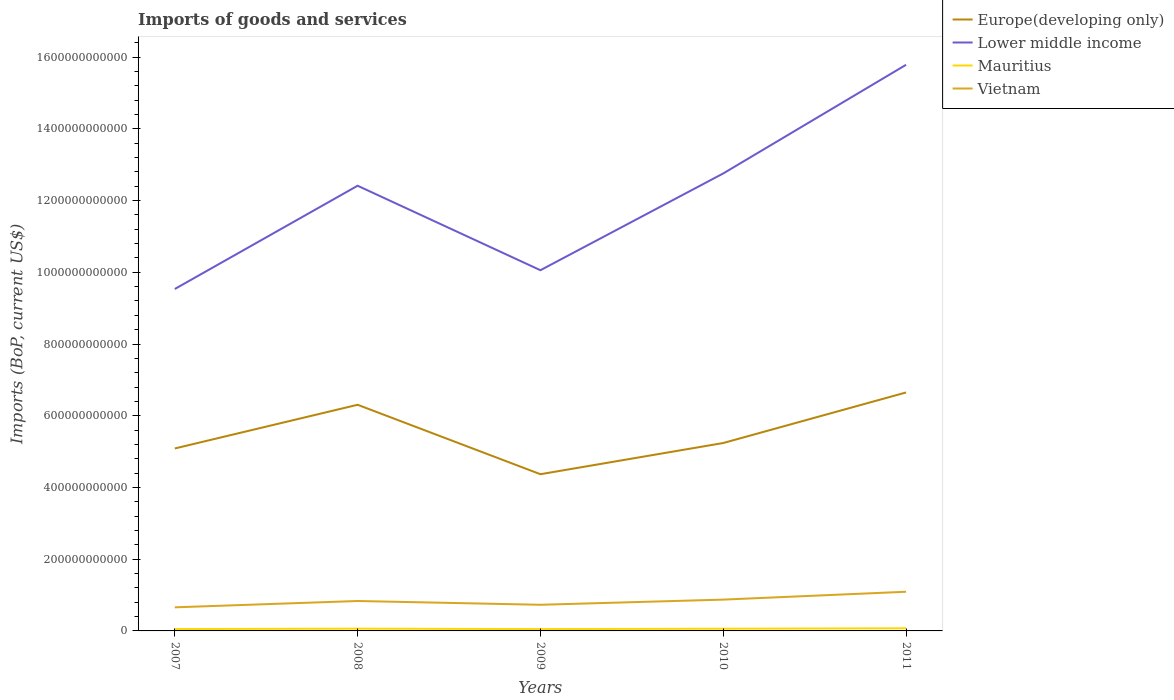How many different coloured lines are there?
Provide a succinct answer. 4. Does the line corresponding to Mauritius intersect with the line corresponding to Europe(developing only)?
Provide a short and direct response. No. Is the number of lines equal to the number of legend labels?
Ensure brevity in your answer.  Yes. Across all years, what is the maximum amount spent on imports in Mauritius?
Your answer should be compact. 5.11e+09. What is the total amount spent on imports in Europe(developing only) in the graph?
Provide a succinct answer. 7.18e+1. What is the difference between the highest and the second highest amount spent on imports in Vietnam?
Ensure brevity in your answer.  4.34e+1. What is the difference between the highest and the lowest amount spent on imports in Europe(developing only)?
Give a very brief answer. 2. Is the amount spent on imports in Vietnam strictly greater than the amount spent on imports in Europe(developing only) over the years?
Your answer should be very brief. Yes. How many years are there in the graph?
Offer a terse response. 5. What is the difference between two consecutive major ticks on the Y-axis?
Make the answer very short. 2.00e+11. Are the values on the major ticks of Y-axis written in scientific E-notation?
Keep it short and to the point. No. Does the graph contain any zero values?
Your answer should be compact. No. Where does the legend appear in the graph?
Your answer should be very brief. Top right. How many legend labels are there?
Offer a terse response. 4. What is the title of the graph?
Provide a short and direct response. Imports of goods and services. Does "Benin" appear as one of the legend labels in the graph?
Provide a succinct answer. No. What is the label or title of the Y-axis?
Provide a succinct answer. Imports (BoP, current US$). What is the Imports (BoP, current US$) in Europe(developing only) in 2007?
Your response must be concise. 5.09e+11. What is the Imports (BoP, current US$) in Lower middle income in 2007?
Your answer should be compact. 9.53e+11. What is the Imports (BoP, current US$) in Mauritius in 2007?
Give a very brief answer. 5.23e+09. What is the Imports (BoP, current US$) of Vietnam in 2007?
Your answer should be compact. 6.58e+1. What is the Imports (BoP, current US$) of Europe(developing only) in 2008?
Ensure brevity in your answer.  6.31e+11. What is the Imports (BoP, current US$) in Lower middle income in 2008?
Ensure brevity in your answer.  1.24e+12. What is the Imports (BoP, current US$) of Mauritius in 2008?
Give a very brief answer. 6.31e+09. What is the Imports (BoP, current US$) of Vietnam in 2008?
Make the answer very short. 8.34e+1. What is the Imports (BoP, current US$) in Europe(developing only) in 2009?
Your response must be concise. 4.37e+11. What is the Imports (BoP, current US$) of Lower middle income in 2009?
Your answer should be compact. 1.01e+12. What is the Imports (BoP, current US$) of Mauritius in 2009?
Offer a terse response. 5.11e+09. What is the Imports (BoP, current US$) in Vietnam in 2009?
Offer a very short reply. 7.29e+1. What is the Imports (BoP, current US$) of Europe(developing only) in 2010?
Your answer should be compact. 5.24e+11. What is the Imports (BoP, current US$) in Lower middle income in 2010?
Your answer should be very brief. 1.28e+12. What is the Imports (BoP, current US$) of Mauritius in 2010?
Provide a short and direct response. 6.14e+09. What is the Imports (BoP, current US$) in Vietnam in 2010?
Your answer should be compact. 8.73e+1. What is the Imports (BoP, current US$) of Europe(developing only) in 2011?
Ensure brevity in your answer.  6.65e+11. What is the Imports (BoP, current US$) of Lower middle income in 2011?
Your response must be concise. 1.58e+12. What is the Imports (BoP, current US$) in Mauritius in 2011?
Your answer should be very brief. 7.39e+09. What is the Imports (BoP, current US$) in Vietnam in 2011?
Your answer should be compact. 1.09e+11. Across all years, what is the maximum Imports (BoP, current US$) in Europe(developing only)?
Give a very brief answer. 6.65e+11. Across all years, what is the maximum Imports (BoP, current US$) in Lower middle income?
Give a very brief answer. 1.58e+12. Across all years, what is the maximum Imports (BoP, current US$) of Mauritius?
Your answer should be very brief. 7.39e+09. Across all years, what is the maximum Imports (BoP, current US$) in Vietnam?
Keep it short and to the point. 1.09e+11. Across all years, what is the minimum Imports (BoP, current US$) in Europe(developing only)?
Ensure brevity in your answer.  4.37e+11. Across all years, what is the minimum Imports (BoP, current US$) in Lower middle income?
Keep it short and to the point. 9.53e+11. Across all years, what is the minimum Imports (BoP, current US$) in Mauritius?
Ensure brevity in your answer.  5.11e+09. Across all years, what is the minimum Imports (BoP, current US$) of Vietnam?
Make the answer very short. 6.58e+1. What is the total Imports (BoP, current US$) in Europe(developing only) in the graph?
Ensure brevity in your answer.  2.77e+12. What is the total Imports (BoP, current US$) in Lower middle income in the graph?
Ensure brevity in your answer.  6.05e+12. What is the total Imports (BoP, current US$) in Mauritius in the graph?
Ensure brevity in your answer.  3.02e+1. What is the total Imports (BoP, current US$) in Vietnam in the graph?
Make the answer very short. 4.19e+11. What is the difference between the Imports (BoP, current US$) of Europe(developing only) in 2007 and that in 2008?
Offer a very short reply. -1.22e+11. What is the difference between the Imports (BoP, current US$) of Lower middle income in 2007 and that in 2008?
Provide a succinct answer. -2.88e+11. What is the difference between the Imports (BoP, current US$) of Mauritius in 2007 and that in 2008?
Your answer should be compact. -1.08e+09. What is the difference between the Imports (BoP, current US$) in Vietnam in 2007 and that in 2008?
Offer a terse response. -1.76e+1. What is the difference between the Imports (BoP, current US$) in Europe(developing only) in 2007 and that in 2009?
Offer a very short reply. 7.18e+1. What is the difference between the Imports (BoP, current US$) of Lower middle income in 2007 and that in 2009?
Provide a succinct answer. -5.24e+1. What is the difference between the Imports (BoP, current US$) of Mauritius in 2007 and that in 2009?
Give a very brief answer. 1.14e+08. What is the difference between the Imports (BoP, current US$) in Vietnam in 2007 and that in 2009?
Keep it short and to the point. -7.11e+09. What is the difference between the Imports (BoP, current US$) of Europe(developing only) in 2007 and that in 2010?
Keep it short and to the point. -1.52e+1. What is the difference between the Imports (BoP, current US$) in Lower middle income in 2007 and that in 2010?
Provide a succinct answer. -3.22e+11. What is the difference between the Imports (BoP, current US$) in Mauritius in 2007 and that in 2010?
Ensure brevity in your answer.  -9.11e+08. What is the difference between the Imports (BoP, current US$) of Vietnam in 2007 and that in 2010?
Ensure brevity in your answer.  -2.15e+1. What is the difference between the Imports (BoP, current US$) of Europe(developing only) in 2007 and that in 2011?
Make the answer very short. -1.56e+11. What is the difference between the Imports (BoP, current US$) in Lower middle income in 2007 and that in 2011?
Your answer should be very brief. -6.25e+11. What is the difference between the Imports (BoP, current US$) in Mauritius in 2007 and that in 2011?
Offer a terse response. -2.16e+09. What is the difference between the Imports (BoP, current US$) of Vietnam in 2007 and that in 2011?
Keep it short and to the point. -4.34e+1. What is the difference between the Imports (BoP, current US$) of Europe(developing only) in 2008 and that in 2009?
Offer a terse response. 1.94e+11. What is the difference between the Imports (BoP, current US$) of Lower middle income in 2008 and that in 2009?
Your answer should be compact. 2.36e+11. What is the difference between the Imports (BoP, current US$) of Mauritius in 2008 and that in 2009?
Your answer should be compact. 1.19e+09. What is the difference between the Imports (BoP, current US$) in Vietnam in 2008 and that in 2009?
Give a very brief answer. 1.05e+1. What is the difference between the Imports (BoP, current US$) of Europe(developing only) in 2008 and that in 2010?
Your response must be concise. 1.07e+11. What is the difference between the Imports (BoP, current US$) of Lower middle income in 2008 and that in 2010?
Your answer should be very brief. -3.43e+1. What is the difference between the Imports (BoP, current US$) of Mauritius in 2008 and that in 2010?
Your answer should be very brief. 1.70e+08. What is the difference between the Imports (BoP, current US$) in Vietnam in 2008 and that in 2010?
Keep it short and to the point. -3.87e+09. What is the difference between the Imports (BoP, current US$) of Europe(developing only) in 2008 and that in 2011?
Make the answer very short. -3.43e+1. What is the difference between the Imports (BoP, current US$) of Lower middle income in 2008 and that in 2011?
Provide a succinct answer. -3.37e+11. What is the difference between the Imports (BoP, current US$) of Mauritius in 2008 and that in 2011?
Give a very brief answer. -1.08e+09. What is the difference between the Imports (BoP, current US$) of Vietnam in 2008 and that in 2011?
Offer a terse response. -2.58e+1. What is the difference between the Imports (BoP, current US$) of Europe(developing only) in 2009 and that in 2010?
Offer a terse response. -8.70e+1. What is the difference between the Imports (BoP, current US$) of Lower middle income in 2009 and that in 2010?
Your answer should be very brief. -2.70e+11. What is the difference between the Imports (BoP, current US$) of Mauritius in 2009 and that in 2010?
Your answer should be compact. -1.02e+09. What is the difference between the Imports (BoP, current US$) in Vietnam in 2009 and that in 2010?
Provide a short and direct response. -1.44e+1. What is the difference between the Imports (BoP, current US$) in Europe(developing only) in 2009 and that in 2011?
Provide a succinct answer. -2.28e+11. What is the difference between the Imports (BoP, current US$) of Lower middle income in 2009 and that in 2011?
Offer a terse response. -5.73e+11. What is the difference between the Imports (BoP, current US$) of Mauritius in 2009 and that in 2011?
Offer a very short reply. -2.28e+09. What is the difference between the Imports (BoP, current US$) in Vietnam in 2009 and that in 2011?
Offer a terse response. -3.63e+1. What is the difference between the Imports (BoP, current US$) in Europe(developing only) in 2010 and that in 2011?
Your response must be concise. -1.41e+11. What is the difference between the Imports (BoP, current US$) of Lower middle income in 2010 and that in 2011?
Keep it short and to the point. -3.03e+11. What is the difference between the Imports (BoP, current US$) in Mauritius in 2010 and that in 2011?
Your response must be concise. -1.25e+09. What is the difference between the Imports (BoP, current US$) in Vietnam in 2010 and that in 2011?
Offer a very short reply. -2.19e+1. What is the difference between the Imports (BoP, current US$) in Europe(developing only) in 2007 and the Imports (BoP, current US$) in Lower middle income in 2008?
Ensure brevity in your answer.  -7.33e+11. What is the difference between the Imports (BoP, current US$) in Europe(developing only) in 2007 and the Imports (BoP, current US$) in Mauritius in 2008?
Provide a succinct answer. 5.02e+11. What is the difference between the Imports (BoP, current US$) in Europe(developing only) in 2007 and the Imports (BoP, current US$) in Vietnam in 2008?
Ensure brevity in your answer.  4.25e+11. What is the difference between the Imports (BoP, current US$) in Lower middle income in 2007 and the Imports (BoP, current US$) in Mauritius in 2008?
Your answer should be very brief. 9.47e+11. What is the difference between the Imports (BoP, current US$) of Lower middle income in 2007 and the Imports (BoP, current US$) of Vietnam in 2008?
Keep it short and to the point. 8.70e+11. What is the difference between the Imports (BoP, current US$) of Mauritius in 2007 and the Imports (BoP, current US$) of Vietnam in 2008?
Keep it short and to the point. -7.82e+1. What is the difference between the Imports (BoP, current US$) of Europe(developing only) in 2007 and the Imports (BoP, current US$) of Lower middle income in 2009?
Your answer should be very brief. -4.97e+11. What is the difference between the Imports (BoP, current US$) in Europe(developing only) in 2007 and the Imports (BoP, current US$) in Mauritius in 2009?
Your answer should be very brief. 5.04e+11. What is the difference between the Imports (BoP, current US$) in Europe(developing only) in 2007 and the Imports (BoP, current US$) in Vietnam in 2009?
Give a very brief answer. 4.36e+11. What is the difference between the Imports (BoP, current US$) of Lower middle income in 2007 and the Imports (BoP, current US$) of Mauritius in 2009?
Keep it short and to the point. 9.48e+11. What is the difference between the Imports (BoP, current US$) in Lower middle income in 2007 and the Imports (BoP, current US$) in Vietnam in 2009?
Your response must be concise. 8.81e+11. What is the difference between the Imports (BoP, current US$) in Mauritius in 2007 and the Imports (BoP, current US$) in Vietnam in 2009?
Your answer should be compact. -6.77e+1. What is the difference between the Imports (BoP, current US$) in Europe(developing only) in 2007 and the Imports (BoP, current US$) in Lower middle income in 2010?
Ensure brevity in your answer.  -7.67e+11. What is the difference between the Imports (BoP, current US$) in Europe(developing only) in 2007 and the Imports (BoP, current US$) in Mauritius in 2010?
Your response must be concise. 5.03e+11. What is the difference between the Imports (BoP, current US$) in Europe(developing only) in 2007 and the Imports (BoP, current US$) in Vietnam in 2010?
Your answer should be compact. 4.21e+11. What is the difference between the Imports (BoP, current US$) of Lower middle income in 2007 and the Imports (BoP, current US$) of Mauritius in 2010?
Provide a short and direct response. 9.47e+11. What is the difference between the Imports (BoP, current US$) of Lower middle income in 2007 and the Imports (BoP, current US$) of Vietnam in 2010?
Ensure brevity in your answer.  8.66e+11. What is the difference between the Imports (BoP, current US$) in Mauritius in 2007 and the Imports (BoP, current US$) in Vietnam in 2010?
Your response must be concise. -8.21e+1. What is the difference between the Imports (BoP, current US$) in Europe(developing only) in 2007 and the Imports (BoP, current US$) in Lower middle income in 2011?
Your answer should be compact. -1.07e+12. What is the difference between the Imports (BoP, current US$) in Europe(developing only) in 2007 and the Imports (BoP, current US$) in Mauritius in 2011?
Make the answer very short. 5.01e+11. What is the difference between the Imports (BoP, current US$) in Europe(developing only) in 2007 and the Imports (BoP, current US$) in Vietnam in 2011?
Give a very brief answer. 4.00e+11. What is the difference between the Imports (BoP, current US$) of Lower middle income in 2007 and the Imports (BoP, current US$) of Mauritius in 2011?
Your response must be concise. 9.46e+11. What is the difference between the Imports (BoP, current US$) of Lower middle income in 2007 and the Imports (BoP, current US$) of Vietnam in 2011?
Provide a short and direct response. 8.44e+11. What is the difference between the Imports (BoP, current US$) in Mauritius in 2007 and the Imports (BoP, current US$) in Vietnam in 2011?
Give a very brief answer. -1.04e+11. What is the difference between the Imports (BoP, current US$) of Europe(developing only) in 2008 and the Imports (BoP, current US$) of Lower middle income in 2009?
Provide a succinct answer. -3.75e+11. What is the difference between the Imports (BoP, current US$) of Europe(developing only) in 2008 and the Imports (BoP, current US$) of Mauritius in 2009?
Provide a succinct answer. 6.25e+11. What is the difference between the Imports (BoP, current US$) of Europe(developing only) in 2008 and the Imports (BoP, current US$) of Vietnam in 2009?
Give a very brief answer. 5.58e+11. What is the difference between the Imports (BoP, current US$) in Lower middle income in 2008 and the Imports (BoP, current US$) in Mauritius in 2009?
Ensure brevity in your answer.  1.24e+12. What is the difference between the Imports (BoP, current US$) of Lower middle income in 2008 and the Imports (BoP, current US$) of Vietnam in 2009?
Ensure brevity in your answer.  1.17e+12. What is the difference between the Imports (BoP, current US$) of Mauritius in 2008 and the Imports (BoP, current US$) of Vietnam in 2009?
Your answer should be compact. -6.66e+1. What is the difference between the Imports (BoP, current US$) in Europe(developing only) in 2008 and the Imports (BoP, current US$) in Lower middle income in 2010?
Ensure brevity in your answer.  -6.45e+11. What is the difference between the Imports (BoP, current US$) of Europe(developing only) in 2008 and the Imports (BoP, current US$) of Mauritius in 2010?
Provide a short and direct response. 6.24e+11. What is the difference between the Imports (BoP, current US$) in Europe(developing only) in 2008 and the Imports (BoP, current US$) in Vietnam in 2010?
Your answer should be compact. 5.43e+11. What is the difference between the Imports (BoP, current US$) of Lower middle income in 2008 and the Imports (BoP, current US$) of Mauritius in 2010?
Make the answer very short. 1.24e+12. What is the difference between the Imports (BoP, current US$) in Lower middle income in 2008 and the Imports (BoP, current US$) in Vietnam in 2010?
Offer a terse response. 1.15e+12. What is the difference between the Imports (BoP, current US$) of Mauritius in 2008 and the Imports (BoP, current US$) of Vietnam in 2010?
Your answer should be compact. -8.10e+1. What is the difference between the Imports (BoP, current US$) in Europe(developing only) in 2008 and the Imports (BoP, current US$) in Lower middle income in 2011?
Offer a terse response. -9.48e+11. What is the difference between the Imports (BoP, current US$) in Europe(developing only) in 2008 and the Imports (BoP, current US$) in Mauritius in 2011?
Offer a terse response. 6.23e+11. What is the difference between the Imports (BoP, current US$) of Europe(developing only) in 2008 and the Imports (BoP, current US$) of Vietnam in 2011?
Keep it short and to the point. 5.21e+11. What is the difference between the Imports (BoP, current US$) in Lower middle income in 2008 and the Imports (BoP, current US$) in Mauritius in 2011?
Your response must be concise. 1.23e+12. What is the difference between the Imports (BoP, current US$) in Lower middle income in 2008 and the Imports (BoP, current US$) in Vietnam in 2011?
Your response must be concise. 1.13e+12. What is the difference between the Imports (BoP, current US$) in Mauritius in 2008 and the Imports (BoP, current US$) in Vietnam in 2011?
Offer a very short reply. -1.03e+11. What is the difference between the Imports (BoP, current US$) in Europe(developing only) in 2009 and the Imports (BoP, current US$) in Lower middle income in 2010?
Make the answer very short. -8.39e+11. What is the difference between the Imports (BoP, current US$) in Europe(developing only) in 2009 and the Imports (BoP, current US$) in Mauritius in 2010?
Ensure brevity in your answer.  4.31e+11. What is the difference between the Imports (BoP, current US$) of Europe(developing only) in 2009 and the Imports (BoP, current US$) of Vietnam in 2010?
Give a very brief answer. 3.50e+11. What is the difference between the Imports (BoP, current US$) in Lower middle income in 2009 and the Imports (BoP, current US$) in Mauritius in 2010?
Offer a very short reply. 1.00e+12. What is the difference between the Imports (BoP, current US$) of Lower middle income in 2009 and the Imports (BoP, current US$) of Vietnam in 2010?
Keep it short and to the point. 9.19e+11. What is the difference between the Imports (BoP, current US$) in Mauritius in 2009 and the Imports (BoP, current US$) in Vietnam in 2010?
Your answer should be very brief. -8.22e+1. What is the difference between the Imports (BoP, current US$) in Europe(developing only) in 2009 and the Imports (BoP, current US$) in Lower middle income in 2011?
Offer a very short reply. -1.14e+12. What is the difference between the Imports (BoP, current US$) in Europe(developing only) in 2009 and the Imports (BoP, current US$) in Mauritius in 2011?
Make the answer very short. 4.30e+11. What is the difference between the Imports (BoP, current US$) of Europe(developing only) in 2009 and the Imports (BoP, current US$) of Vietnam in 2011?
Keep it short and to the point. 3.28e+11. What is the difference between the Imports (BoP, current US$) of Lower middle income in 2009 and the Imports (BoP, current US$) of Mauritius in 2011?
Give a very brief answer. 9.98e+11. What is the difference between the Imports (BoP, current US$) in Lower middle income in 2009 and the Imports (BoP, current US$) in Vietnam in 2011?
Make the answer very short. 8.97e+11. What is the difference between the Imports (BoP, current US$) in Mauritius in 2009 and the Imports (BoP, current US$) in Vietnam in 2011?
Offer a very short reply. -1.04e+11. What is the difference between the Imports (BoP, current US$) in Europe(developing only) in 2010 and the Imports (BoP, current US$) in Lower middle income in 2011?
Ensure brevity in your answer.  -1.05e+12. What is the difference between the Imports (BoP, current US$) of Europe(developing only) in 2010 and the Imports (BoP, current US$) of Mauritius in 2011?
Provide a short and direct response. 5.17e+11. What is the difference between the Imports (BoP, current US$) in Europe(developing only) in 2010 and the Imports (BoP, current US$) in Vietnam in 2011?
Offer a very short reply. 4.15e+11. What is the difference between the Imports (BoP, current US$) in Lower middle income in 2010 and the Imports (BoP, current US$) in Mauritius in 2011?
Ensure brevity in your answer.  1.27e+12. What is the difference between the Imports (BoP, current US$) in Lower middle income in 2010 and the Imports (BoP, current US$) in Vietnam in 2011?
Provide a short and direct response. 1.17e+12. What is the difference between the Imports (BoP, current US$) in Mauritius in 2010 and the Imports (BoP, current US$) in Vietnam in 2011?
Make the answer very short. -1.03e+11. What is the average Imports (BoP, current US$) of Europe(developing only) per year?
Keep it short and to the point. 5.53e+11. What is the average Imports (BoP, current US$) of Lower middle income per year?
Provide a short and direct response. 1.21e+12. What is the average Imports (BoP, current US$) in Mauritius per year?
Your answer should be compact. 6.03e+09. What is the average Imports (BoP, current US$) in Vietnam per year?
Give a very brief answer. 8.37e+1. In the year 2007, what is the difference between the Imports (BoP, current US$) in Europe(developing only) and Imports (BoP, current US$) in Lower middle income?
Provide a short and direct response. -4.45e+11. In the year 2007, what is the difference between the Imports (BoP, current US$) in Europe(developing only) and Imports (BoP, current US$) in Mauritius?
Offer a terse response. 5.04e+11. In the year 2007, what is the difference between the Imports (BoP, current US$) in Europe(developing only) and Imports (BoP, current US$) in Vietnam?
Provide a succinct answer. 4.43e+11. In the year 2007, what is the difference between the Imports (BoP, current US$) in Lower middle income and Imports (BoP, current US$) in Mauritius?
Offer a terse response. 9.48e+11. In the year 2007, what is the difference between the Imports (BoP, current US$) in Lower middle income and Imports (BoP, current US$) in Vietnam?
Provide a succinct answer. 8.88e+11. In the year 2007, what is the difference between the Imports (BoP, current US$) of Mauritius and Imports (BoP, current US$) of Vietnam?
Your answer should be compact. -6.06e+1. In the year 2008, what is the difference between the Imports (BoP, current US$) in Europe(developing only) and Imports (BoP, current US$) in Lower middle income?
Provide a short and direct response. -6.11e+11. In the year 2008, what is the difference between the Imports (BoP, current US$) of Europe(developing only) and Imports (BoP, current US$) of Mauritius?
Give a very brief answer. 6.24e+11. In the year 2008, what is the difference between the Imports (BoP, current US$) of Europe(developing only) and Imports (BoP, current US$) of Vietnam?
Ensure brevity in your answer.  5.47e+11. In the year 2008, what is the difference between the Imports (BoP, current US$) in Lower middle income and Imports (BoP, current US$) in Mauritius?
Make the answer very short. 1.24e+12. In the year 2008, what is the difference between the Imports (BoP, current US$) in Lower middle income and Imports (BoP, current US$) in Vietnam?
Offer a terse response. 1.16e+12. In the year 2008, what is the difference between the Imports (BoP, current US$) in Mauritius and Imports (BoP, current US$) in Vietnam?
Ensure brevity in your answer.  -7.71e+1. In the year 2009, what is the difference between the Imports (BoP, current US$) in Europe(developing only) and Imports (BoP, current US$) in Lower middle income?
Give a very brief answer. -5.69e+11. In the year 2009, what is the difference between the Imports (BoP, current US$) in Europe(developing only) and Imports (BoP, current US$) in Mauritius?
Offer a terse response. 4.32e+11. In the year 2009, what is the difference between the Imports (BoP, current US$) in Europe(developing only) and Imports (BoP, current US$) in Vietnam?
Your answer should be compact. 3.64e+11. In the year 2009, what is the difference between the Imports (BoP, current US$) in Lower middle income and Imports (BoP, current US$) in Mauritius?
Ensure brevity in your answer.  1.00e+12. In the year 2009, what is the difference between the Imports (BoP, current US$) in Lower middle income and Imports (BoP, current US$) in Vietnam?
Your answer should be compact. 9.33e+11. In the year 2009, what is the difference between the Imports (BoP, current US$) in Mauritius and Imports (BoP, current US$) in Vietnam?
Your response must be concise. -6.78e+1. In the year 2010, what is the difference between the Imports (BoP, current US$) in Europe(developing only) and Imports (BoP, current US$) in Lower middle income?
Provide a short and direct response. -7.52e+11. In the year 2010, what is the difference between the Imports (BoP, current US$) in Europe(developing only) and Imports (BoP, current US$) in Mauritius?
Offer a very short reply. 5.18e+11. In the year 2010, what is the difference between the Imports (BoP, current US$) of Europe(developing only) and Imports (BoP, current US$) of Vietnam?
Offer a terse response. 4.37e+11. In the year 2010, what is the difference between the Imports (BoP, current US$) of Lower middle income and Imports (BoP, current US$) of Mauritius?
Your answer should be compact. 1.27e+12. In the year 2010, what is the difference between the Imports (BoP, current US$) in Lower middle income and Imports (BoP, current US$) in Vietnam?
Provide a succinct answer. 1.19e+12. In the year 2010, what is the difference between the Imports (BoP, current US$) in Mauritius and Imports (BoP, current US$) in Vietnam?
Make the answer very short. -8.12e+1. In the year 2011, what is the difference between the Imports (BoP, current US$) in Europe(developing only) and Imports (BoP, current US$) in Lower middle income?
Provide a short and direct response. -9.14e+11. In the year 2011, what is the difference between the Imports (BoP, current US$) of Europe(developing only) and Imports (BoP, current US$) of Mauritius?
Your answer should be compact. 6.58e+11. In the year 2011, what is the difference between the Imports (BoP, current US$) of Europe(developing only) and Imports (BoP, current US$) of Vietnam?
Give a very brief answer. 5.56e+11. In the year 2011, what is the difference between the Imports (BoP, current US$) of Lower middle income and Imports (BoP, current US$) of Mauritius?
Offer a very short reply. 1.57e+12. In the year 2011, what is the difference between the Imports (BoP, current US$) of Lower middle income and Imports (BoP, current US$) of Vietnam?
Your response must be concise. 1.47e+12. In the year 2011, what is the difference between the Imports (BoP, current US$) in Mauritius and Imports (BoP, current US$) in Vietnam?
Your answer should be compact. -1.02e+11. What is the ratio of the Imports (BoP, current US$) in Europe(developing only) in 2007 to that in 2008?
Give a very brief answer. 0.81. What is the ratio of the Imports (BoP, current US$) in Lower middle income in 2007 to that in 2008?
Keep it short and to the point. 0.77. What is the ratio of the Imports (BoP, current US$) of Mauritius in 2007 to that in 2008?
Your answer should be very brief. 0.83. What is the ratio of the Imports (BoP, current US$) in Vietnam in 2007 to that in 2008?
Provide a short and direct response. 0.79. What is the ratio of the Imports (BoP, current US$) of Europe(developing only) in 2007 to that in 2009?
Keep it short and to the point. 1.16. What is the ratio of the Imports (BoP, current US$) in Lower middle income in 2007 to that in 2009?
Your response must be concise. 0.95. What is the ratio of the Imports (BoP, current US$) in Mauritius in 2007 to that in 2009?
Offer a terse response. 1.02. What is the ratio of the Imports (BoP, current US$) of Vietnam in 2007 to that in 2009?
Ensure brevity in your answer.  0.9. What is the ratio of the Imports (BoP, current US$) in Europe(developing only) in 2007 to that in 2010?
Your response must be concise. 0.97. What is the ratio of the Imports (BoP, current US$) in Lower middle income in 2007 to that in 2010?
Your response must be concise. 0.75. What is the ratio of the Imports (BoP, current US$) in Mauritius in 2007 to that in 2010?
Make the answer very short. 0.85. What is the ratio of the Imports (BoP, current US$) in Vietnam in 2007 to that in 2010?
Provide a short and direct response. 0.75. What is the ratio of the Imports (BoP, current US$) in Europe(developing only) in 2007 to that in 2011?
Provide a succinct answer. 0.77. What is the ratio of the Imports (BoP, current US$) in Lower middle income in 2007 to that in 2011?
Offer a terse response. 0.6. What is the ratio of the Imports (BoP, current US$) of Mauritius in 2007 to that in 2011?
Keep it short and to the point. 0.71. What is the ratio of the Imports (BoP, current US$) in Vietnam in 2007 to that in 2011?
Offer a very short reply. 0.6. What is the ratio of the Imports (BoP, current US$) of Europe(developing only) in 2008 to that in 2009?
Make the answer very short. 1.44. What is the ratio of the Imports (BoP, current US$) of Lower middle income in 2008 to that in 2009?
Ensure brevity in your answer.  1.23. What is the ratio of the Imports (BoP, current US$) of Mauritius in 2008 to that in 2009?
Give a very brief answer. 1.23. What is the ratio of the Imports (BoP, current US$) in Vietnam in 2008 to that in 2009?
Provide a succinct answer. 1.14. What is the ratio of the Imports (BoP, current US$) of Europe(developing only) in 2008 to that in 2010?
Offer a very short reply. 1.2. What is the ratio of the Imports (BoP, current US$) of Lower middle income in 2008 to that in 2010?
Give a very brief answer. 0.97. What is the ratio of the Imports (BoP, current US$) of Mauritius in 2008 to that in 2010?
Your response must be concise. 1.03. What is the ratio of the Imports (BoP, current US$) of Vietnam in 2008 to that in 2010?
Make the answer very short. 0.96. What is the ratio of the Imports (BoP, current US$) of Europe(developing only) in 2008 to that in 2011?
Give a very brief answer. 0.95. What is the ratio of the Imports (BoP, current US$) in Lower middle income in 2008 to that in 2011?
Give a very brief answer. 0.79. What is the ratio of the Imports (BoP, current US$) of Mauritius in 2008 to that in 2011?
Provide a short and direct response. 0.85. What is the ratio of the Imports (BoP, current US$) of Vietnam in 2008 to that in 2011?
Your answer should be very brief. 0.76. What is the ratio of the Imports (BoP, current US$) of Europe(developing only) in 2009 to that in 2010?
Offer a terse response. 0.83. What is the ratio of the Imports (BoP, current US$) in Lower middle income in 2009 to that in 2010?
Provide a short and direct response. 0.79. What is the ratio of the Imports (BoP, current US$) in Mauritius in 2009 to that in 2010?
Keep it short and to the point. 0.83. What is the ratio of the Imports (BoP, current US$) in Vietnam in 2009 to that in 2010?
Keep it short and to the point. 0.83. What is the ratio of the Imports (BoP, current US$) in Europe(developing only) in 2009 to that in 2011?
Make the answer very short. 0.66. What is the ratio of the Imports (BoP, current US$) of Lower middle income in 2009 to that in 2011?
Provide a succinct answer. 0.64. What is the ratio of the Imports (BoP, current US$) of Mauritius in 2009 to that in 2011?
Give a very brief answer. 0.69. What is the ratio of the Imports (BoP, current US$) in Vietnam in 2009 to that in 2011?
Ensure brevity in your answer.  0.67. What is the ratio of the Imports (BoP, current US$) of Europe(developing only) in 2010 to that in 2011?
Give a very brief answer. 0.79. What is the ratio of the Imports (BoP, current US$) in Lower middle income in 2010 to that in 2011?
Provide a succinct answer. 0.81. What is the ratio of the Imports (BoP, current US$) in Mauritius in 2010 to that in 2011?
Your answer should be very brief. 0.83. What is the ratio of the Imports (BoP, current US$) of Vietnam in 2010 to that in 2011?
Make the answer very short. 0.8. What is the difference between the highest and the second highest Imports (BoP, current US$) in Europe(developing only)?
Offer a very short reply. 3.43e+1. What is the difference between the highest and the second highest Imports (BoP, current US$) in Lower middle income?
Keep it short and to the point. 3.03e+11. What is the difference between the highest and the second highest Imports (BoP, current US$) of Mauritius?
Offer a terse response. 1.08e+09. What is the difference between the highest and the second highest Imports (BoP, current US$) in Vietnam?
Keep it short and to the point. 2.19e+1. What is the difference between the highest and the lowest Imports (BoP, current US$) in Europe(developing only)?
Your answer should be compact. 2.28e+11. What is the difference between the highest and the lowest Imports (BoP, current US$) of Lower middle income?
Provide a short and direct response. 6.25e+11. What is the difference between the highest and the lowest Imports (BoP, current US$) of Mauritius?
Offer a terse response. 2.28e+09. What is the difference between the highest and the lowest Imports (BoP, current US$) of Vietnam?
Your answer should be very brief. 4.34e+1. 